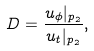Convert formula to latex. <formula><loc_0><loc_0><loc_500><loc_500>D = \frac { u _ { \phi } | _ { p _ { 2 } } } { u _ { t } | _ { p _ { 2 } } } ,</formula> 